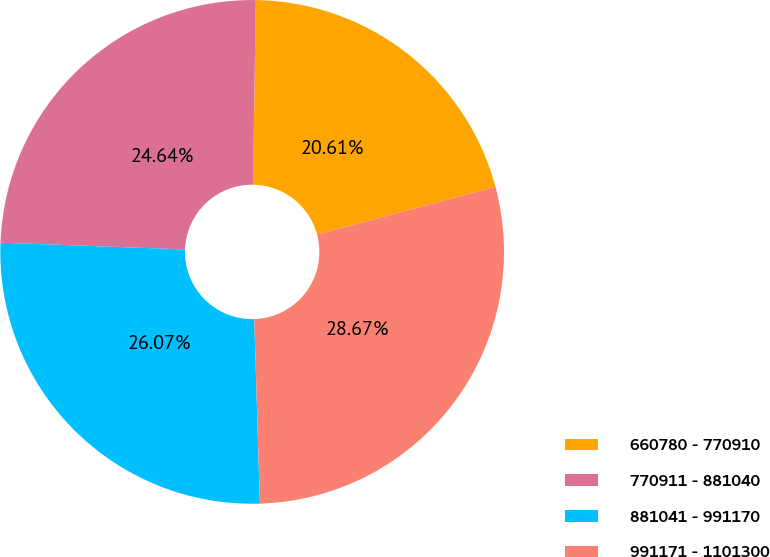Convert chart. <chart><loc_0><loc_0><loc_500><loc_500><pie_chart><fcel>660780 - 770910<fcel>770911 - 881040<fcel>881041 - 991170<fcel>991171 - 1101300<nl><fcel>20.61%<fcel>24.64%<fcel>26.07%<fcel>28.67%<nl></chart> 